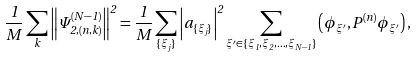<formula> <loc_0><loc_0><loc_500><loc_500>\frac { 1 } { M } \sum _ { k } \left \| \Psi _ { 2 , ( n , k ) } ^ { ( N - 1 ) } \right \| ^ { 2 } = \frac { 1 } { M } \sum _ { \{ \xi _ { j } \} } \left | a _ { \{ \xi _ { j } \} } \right | ^ { 2 } \sum _ { \xi ^ { \prime } \in \{ \xi _ { 1 } , \xi _ { 2 } , \dots , \xi _ { N - 1 } \} } \left ( \phi _ { \xi ^ { \prime } } , P ^ { ( n ) } \phi _ { \xi ^ { \prime } } \right ) ,</formula> 